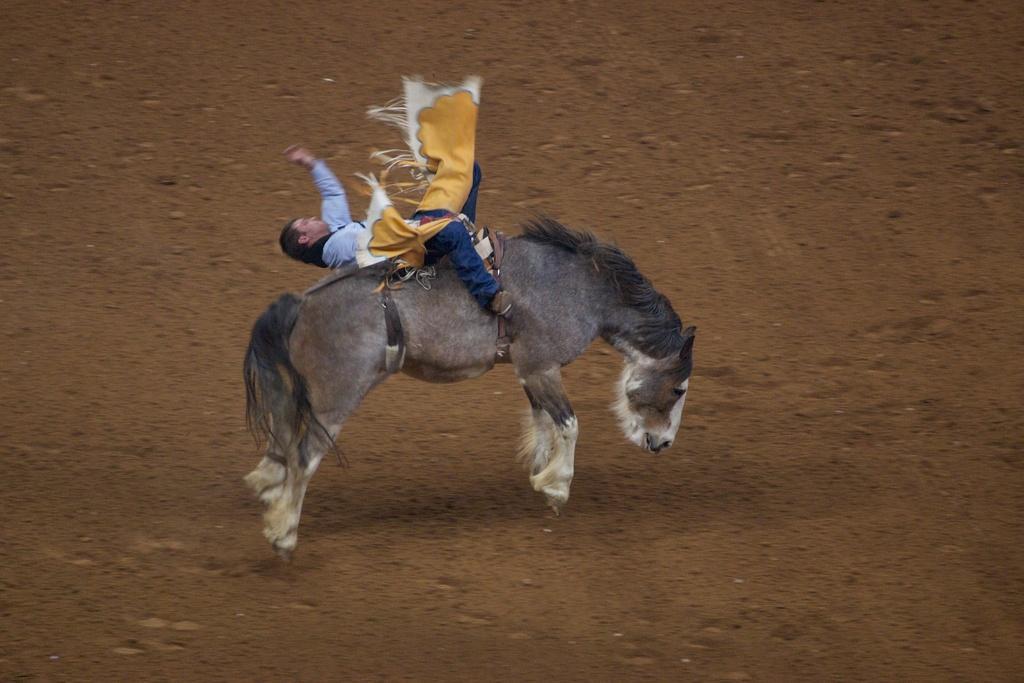Can you describe this image briefly? In this image we can see a person riding a horse on the ground. 